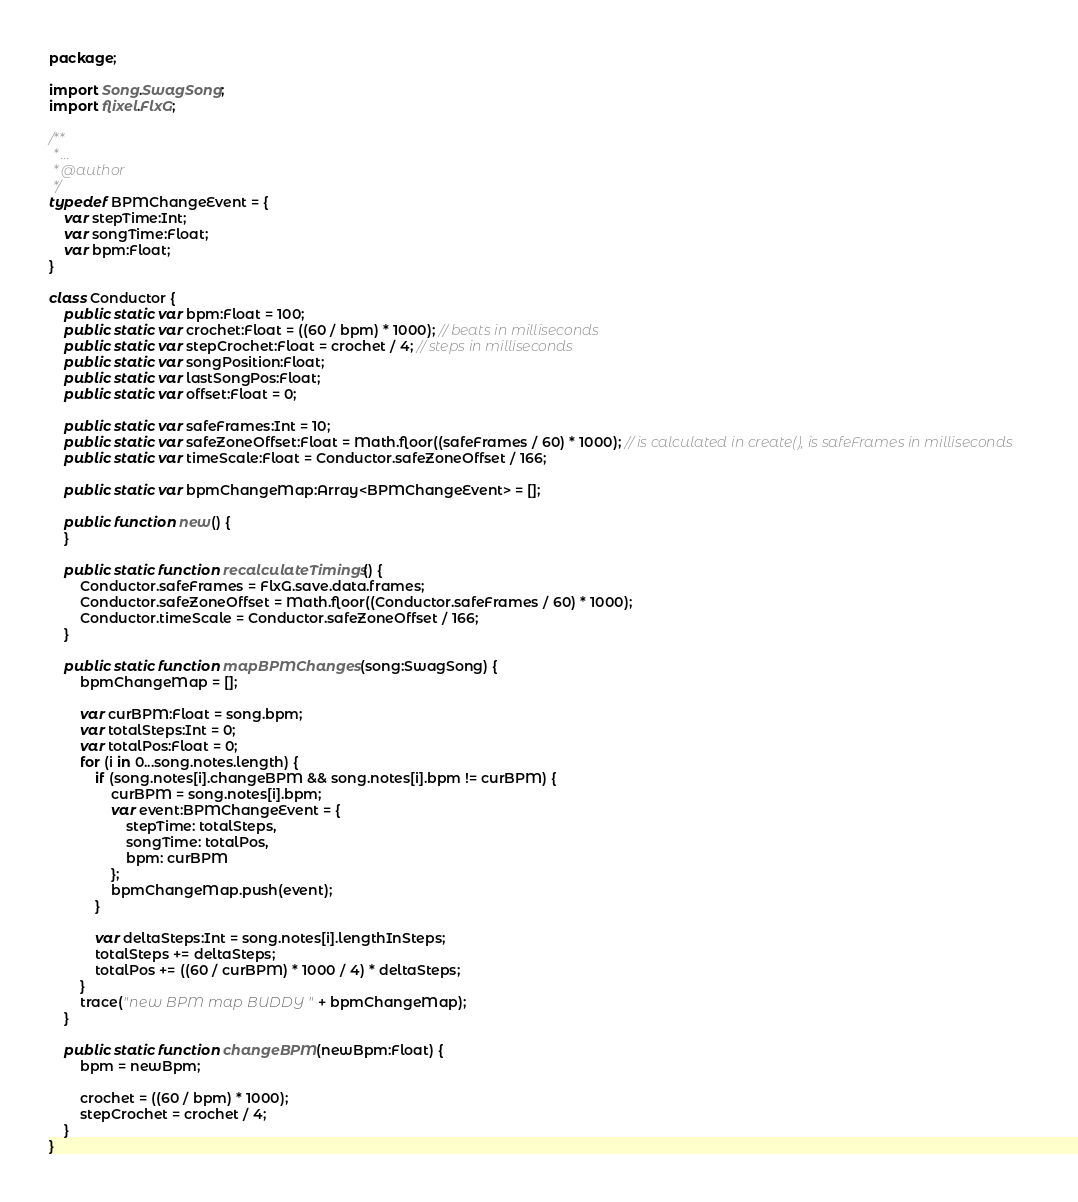Convert code to text. <code><loc_0><loc_0><loc_500><loc_500><_Haxe_>package;

import Song.SwagSong;
import flixel.FlxG;

/**
 * ...
 * @author
 */
typedef BPMChangeEvent = {
	var stepTime:Int;
	var songTime:Float;
	var bpm:Float;
}

class Conductor {
	public static var bpm:Float = 100;
	public static var crochet:Float = ((60 / bpm) * 1000); // beats in milliseconds
	public static var stepCrochet:Float = crochet / 4; // steps in milliseconds
	public static var songPosition:Float;
	public static var lastSongPos:Float;
	public static var offset:Float = 0;

	public static var safeFrames:Int = 10;
	public static var safeZoneOffset:Float = Math.floor((safeFrames / 60) * 1000); // is calculated in create(), is safeFrames in milliseconds
	public static var timeScale:Float = Conductor.safeZoneOffset / 166;

	public static var bpmChangeMap:Array<BPMChangeEvent> = [];

	public function new() {
	}

	public static function recalculateTimings() {
		Conductor.safeFrames = FlxG.save.data.frames;
		Conductor.safeZoneOffset = Math.floor((Conductor.safeFrames / 60) * 1000);
		Conductor.timeScale = Conductor.safeZoneOffset / 166;
	}

	public static function mapBPMChanges(song:SwagSong) {
		bpmChangeMap = [];

		var curBPM:Float = song.bpm;
		var totalSteps:Int = 0;
		var totalPos:Float = 0;
		for (i in 0...song.notes.length) {
			if (song.notes[i].changeBPM && song.notes[i].bpm != curBPM) {
				curBPM = song.notes[i].bpm;
				var event:BPMChangeEvent = {
					stepTime: totalSteps,
					songTime: totalPos,
					bpm: curBPM
				};
				bpmChangeMap.push(event);
			}

			var deltaSteps:Int = song.notes[i].lengthInSteps;
			totalSteps += deltaSteps;
			totalPos += ((60 / curBPM) * 1000 / 4) * deltaSteps;
		}
		trace("new BPM map BUDDY " + bpmChangeMap);
	}

	public static function changeBPM(newBpm:Float) {
		bpm = newBpm;

		crochet = ((60 / bpm) * 1000);
		stepCrochet = crochet / 4;
	}
}
</code> 